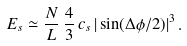<formula> <loc_0><loc_0><loc_500><loc_500>E _ { s } \simeq \frac { N } { L } \, \frac { 4 } { 3 } \, c _ { s } \, | \sin ( \Delta \phi / 2 ) | ^ { 3 } \, .</formula> 